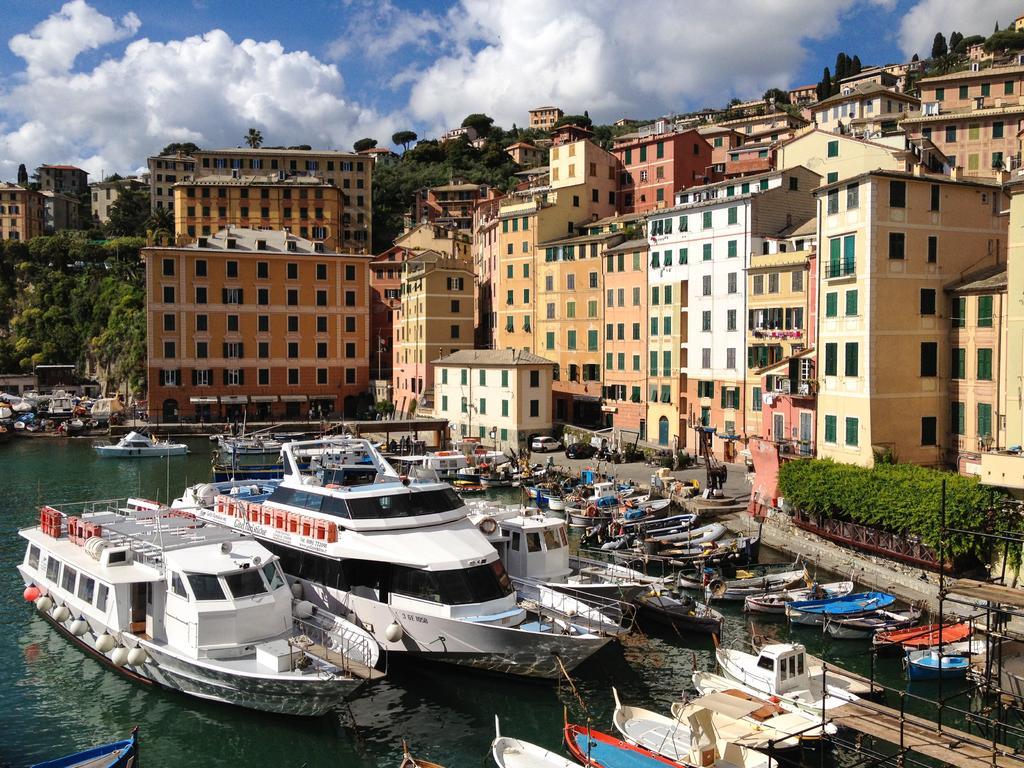Describe this image in one or two sentences. In this picture we can see few boats on the water, beside to the boats we can find few metal rods, shrubs and buildings, and also we can see few trees and clouds. 